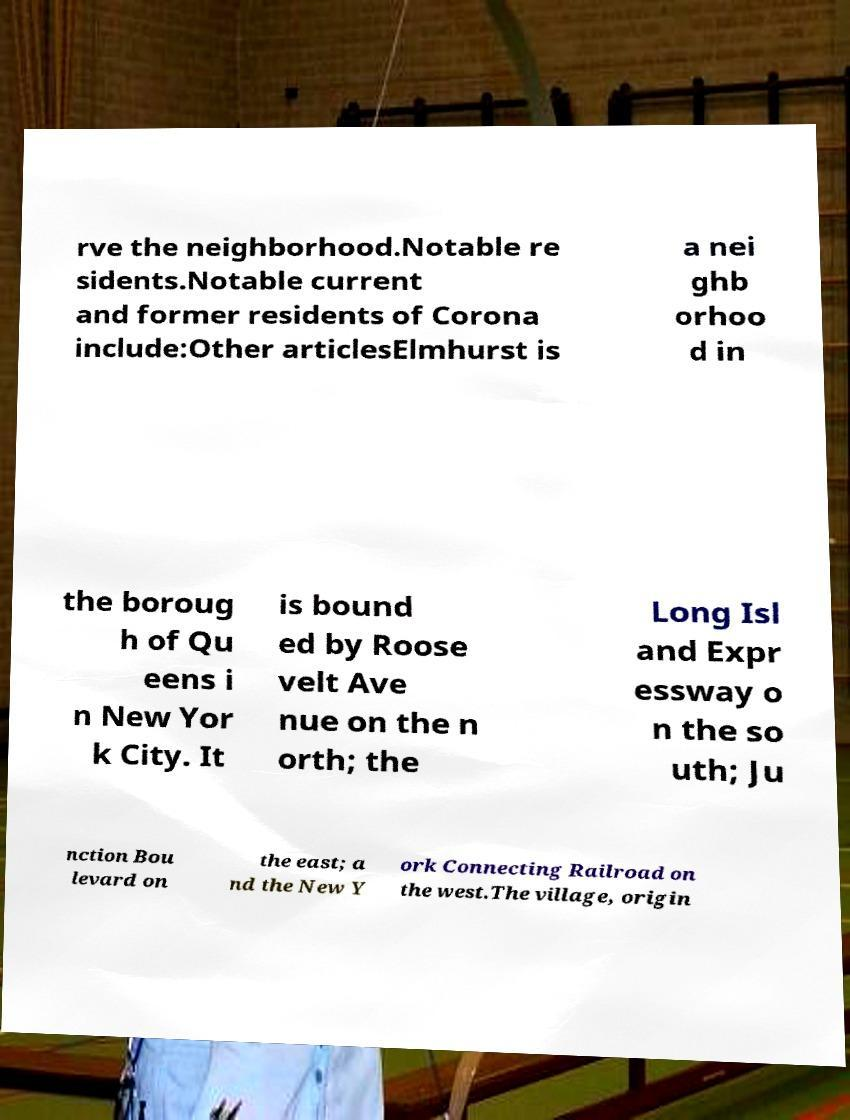Could you assist in decoding the text presented in this image and type it out clearly? rve the neighborhood.Notable re sidents.Notable current and former residents of Corona include:Other articlesElmhurst is a nei ghb orhoo d in the boroug h of Qu eens i n New Yor k City. It is bound ed by Roose velt Ave nue on the n orth; the Long Isl and Expr essway o n the so uth; Ju nction Bou levard on the east; a nd the New Y ork Connecting Railroad on the west.The village, origin 